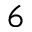Convert formula to latex. <formula><loc_0><loc_0><loc_500><loc_500>^ { 6 }</formula> 